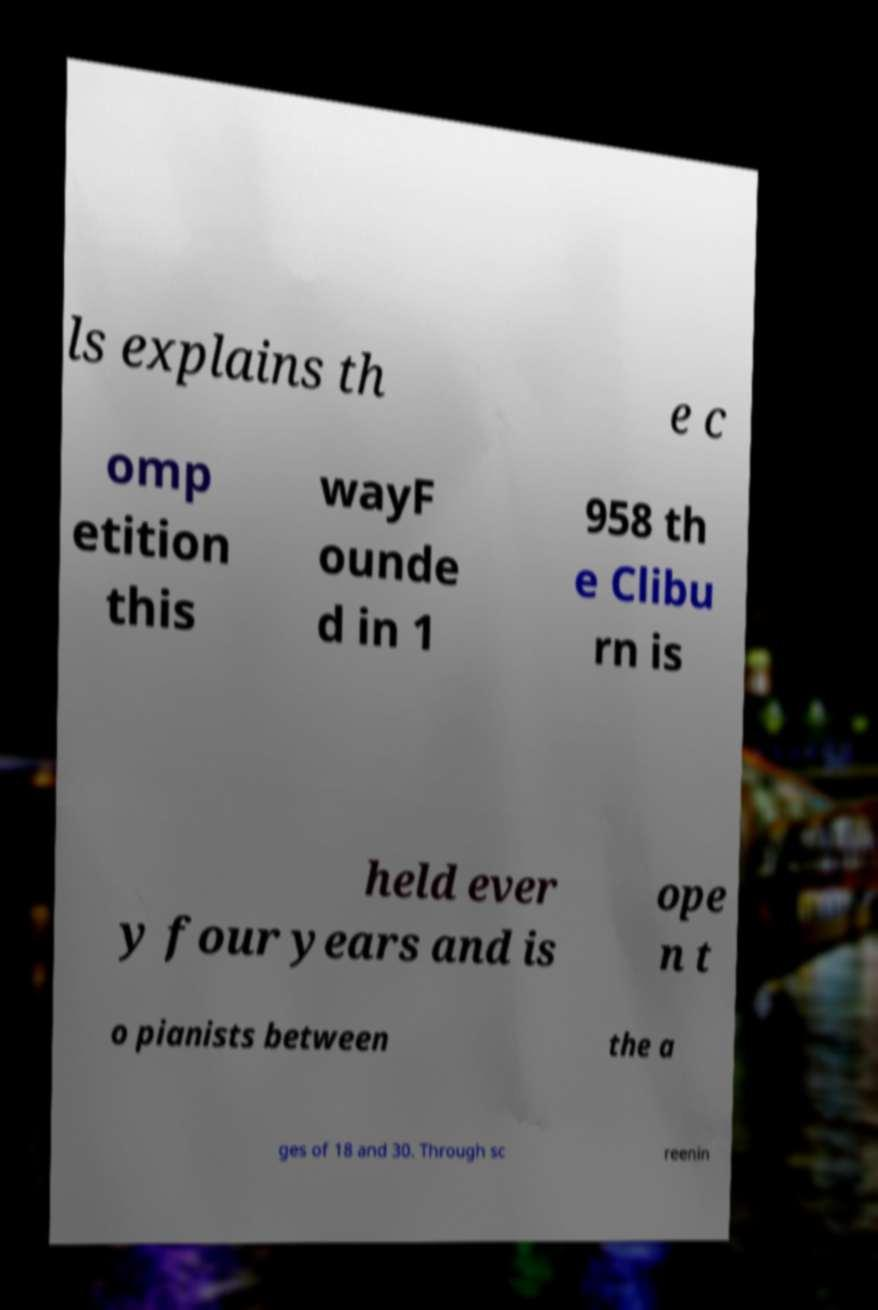For documentation purposes, I need the text within this image transcribed. Could you provide that? ls explains th e c omp etition this wayF ounde d in 1 958 th e Clibu rn is held ever y four years and is ope n t o pianists between the a ges of 18 and 30. Through sc reenin 